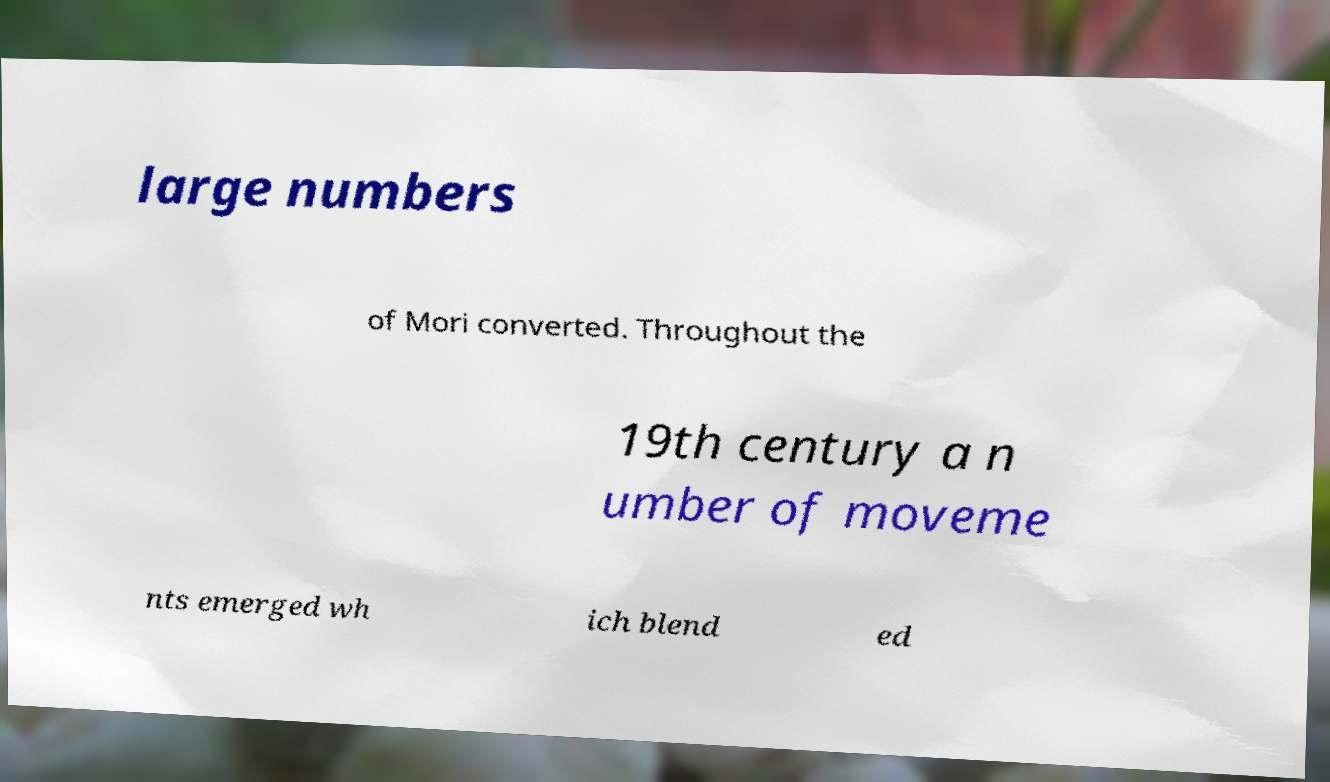Can you accurately transcribe the text from the provided image for me? large numbers of Mori converted. Throughout the 19th century a n umber of moveme nts emerged wh ich blend ed 